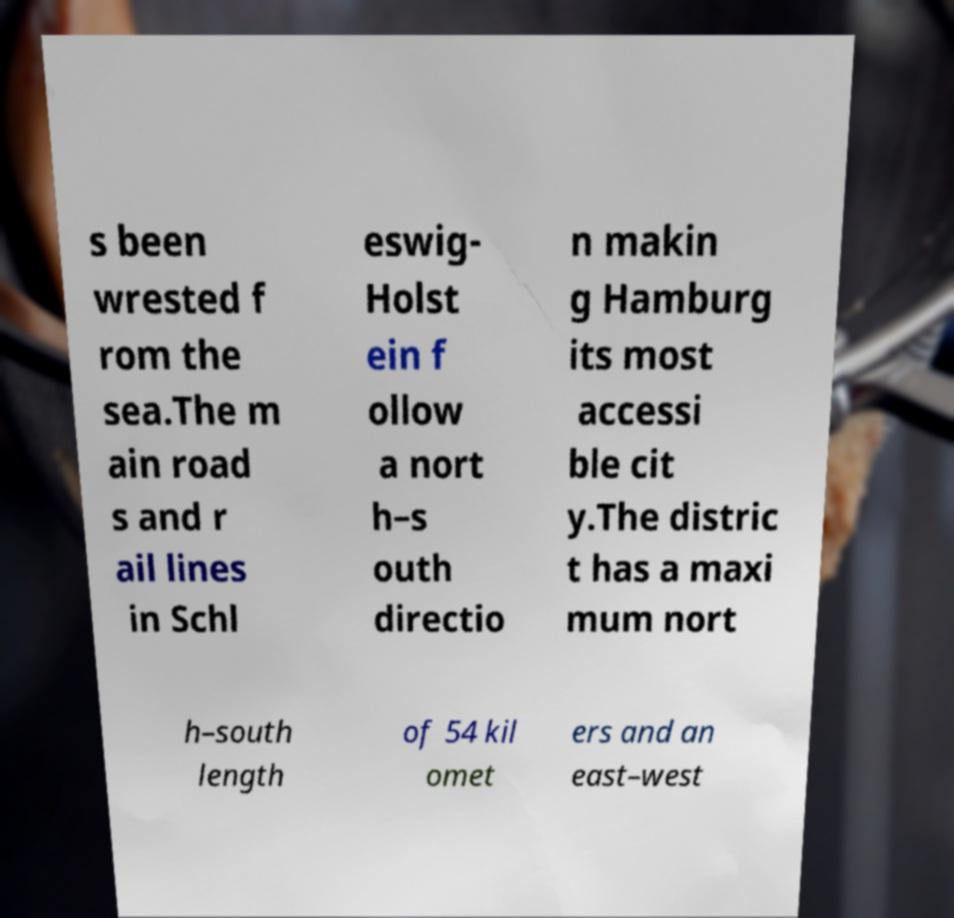Can you accurately transcribe the text from the provided image for me? s been wrested f rom the sea.The m ain road s and r ail lines in Schl eswig- Holst ein f ollow a nort h–s outh directio n makin g Hamburg its most accessi ble cit y.The distric t has a maxi mum nort h–south length of 54 kil omet ers and an east–west 